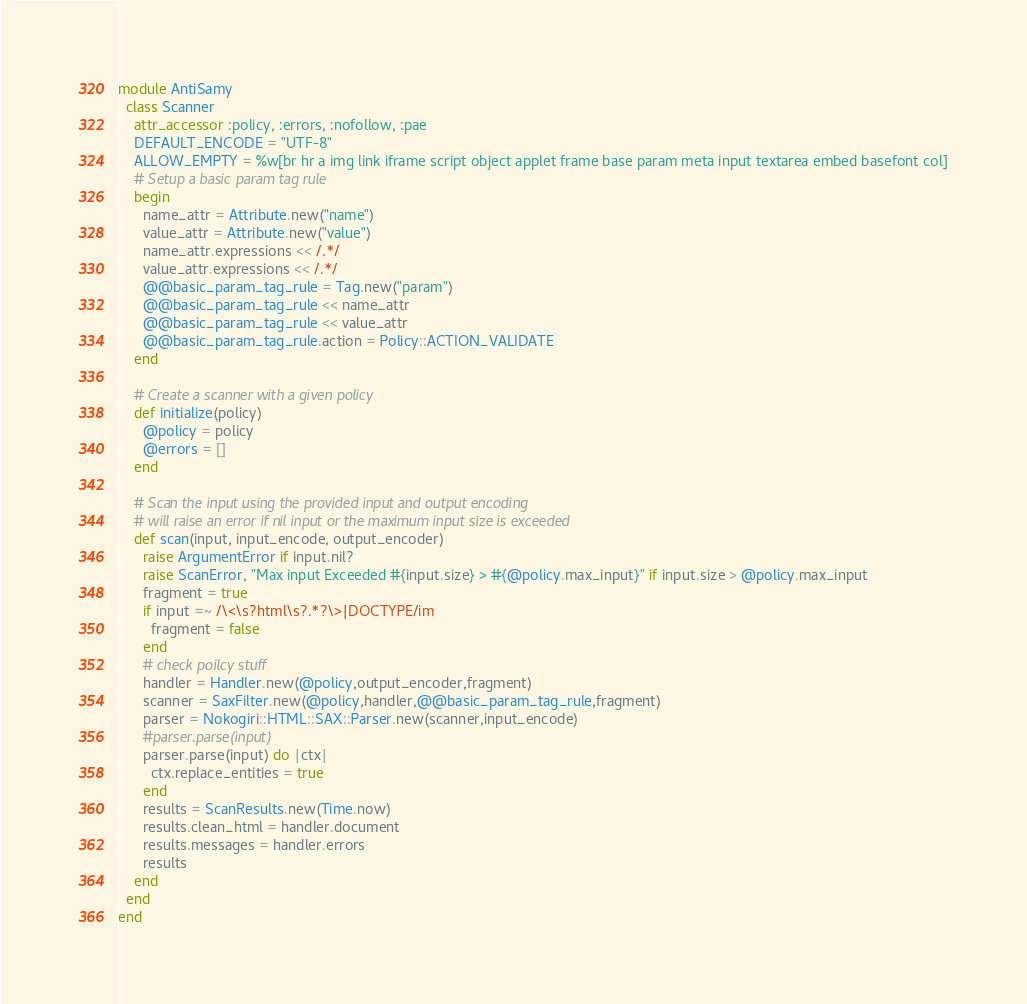<code> <loc_0><loc_0><loc_500><loc_500><_Ruby_>module AntiSamy
  class Scanner
    attr_accessor :policy, :errors, :nofollow, :pae
    DEFAULT_ENCODE = "UTF-8"
    ALLOW_EMPTY = %w[br hr a img link iframe script object applet frame base param meta input textarea embed basefont col]
    # Setup a basic param tag rule
    begin
      name_attr = Attribute.new("name")
      value_attr = Attribute.new("value")
      name_attr.expressions << /.*/
      value_attr.expressions << /.*/
      @@basic_param_tag_rule = Tag.new("param")
      @@basic_param_tag_rule << name_attr
      @@basic_param_tag_rule << value_attr
      @@basic_param_tag_rule.action = Policy::ACTION_VALIDATE
    end

    # Create a scanner with a given policy
    def initialize(policy)
      @policy = policy
      @errors = []
    end

    # Scan the input using the provided input and output encoding
    # will raise an error if nil input or the maximum input size is exceeded
    def scan(input, input_encode, output_encoder)
      raise ArgumentError if input.nil?
      raise ScanError, "Max input Exceeded #{input.size} > #{@policy.max_input}" if input.size > @policy.max_input
	  fragment = true
	  if input =~ /\<\s?html\s?.*?\>|DOCTYPE/im
		fragment = false
	  end
      # check poilcy stuff
      handler = Handler.new(@policy,output_encoder,fragment)
      scanner = SaxFilter.new(@policy,handler,@@basic_param_tag_rule,fragment)
      parser = Nokogiri::HTML::SAX::Parser.new(scanner,input_encode)
      #parser.parse(input)
      parser.parse(input) do |ctx|
        ctx.replace_entities = true
      end
      results = ScanResults.new(Time.now)
      results.clean_html = handler.document
      results.messages = handler.errors
      results
    end
  end
end
</code> 